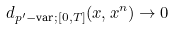<formula> <loc_0><loc_0><loc_500><loc_500>d _ { p ^ { \prime } - \text {var} ; [ 0 , T ] } ( x , x ^ { n } ) \to 0</formula> 